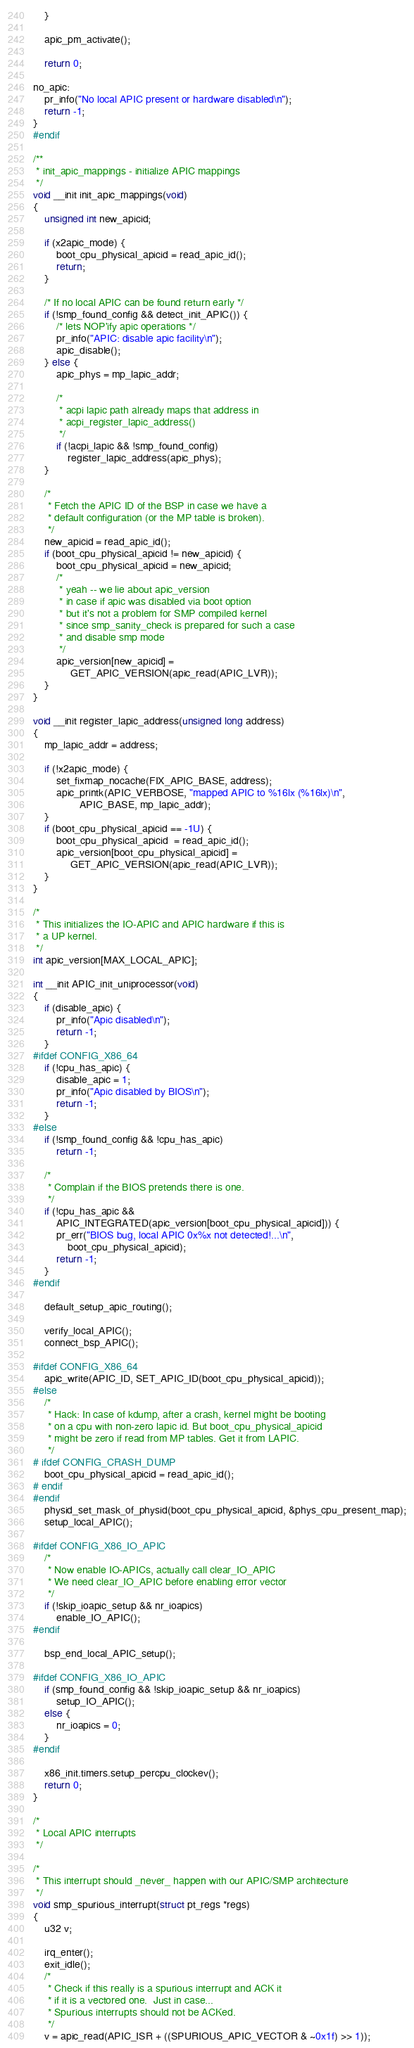Convert code to text. <code><loc_0><loc_0><loc_500><loc_500><_C_>	}

	apic_pm_activate();

	return 0;

no_apic:
	pr_info("No local APIC present or hardware disabled\n");
	return -1;
}
#endif

/**
 * init_apic_mappings - initialize APIC mappings
 */
void __init init_apic_mappings(void)
{
	unsigned int new_apicid;

	if (x2apic_mode) {
		boot_cpu_physical_apicid = read_apic_id();
		return;
	}

	/* If no local APIC can be found return early */
	if (!smp_found_config && detect_init_APIC()) {
		/* lets NOP'ify apic operations */
		pr_info("APIC: disable apic facility\n");
		apic_disable();
	} else {
		apic_phys = mp_lapic_addr;

		/*
		 * acpi lapic path already maps that address in
		 * acpi_register_lapic_address()
		 */
		if (!acpi_lapic && !smp_found_config)
			register_lapic_address(apic_phys);
	}

	/*
	 * Fetch the APIC ID of the BSP in case we have a
	 * default configuration (or the MP table is broken).
	 */
	new_apicid = read_apic_id();
	if (boot_cpu_physical_apicid != new_apicid) {
		boot_cpu_physical_apicid = new_apicid;
		/*
		 * yeah -- we lie about apic_version
		 * in case if apic was disabled via boot option
		 * but it's not a problem for SMP compiled kernel
		 * since smp_sanity_check is prepared for such a case
		 * and disable smp mode
		 */
		apic_version[new_apicid] =
			 GET_APIC_VERSION(apic_read(APIC_LVR));
	}
}

void __init register_lapic_address(unsigned long address)
{
	mp_lapic_addr = address;

	if (!x2apic_mode) {
		set_fixmap_nocache(FIX_APIC_BASE, address);
		apic_printk(APIC_VERBOSE, "mapped APIC to %16lx (%16lx)\n",
			    APIC_BASE, mp_lapic_addr);
	}
	if (boot_cpu_physical_apicid == -1U) {
		boot_cpu_physical_apicid  = read_apic_id();
		apic_version[boot_cpu_physical_apicid] =
			 GET_APIC_VERSION(apic_read(APIC_LVR));
	}
}

/*
 * This initializes the IO-APIC and APIC hardware if this is
 * a UP kernel.
 */
int apic_version[MAX_LOCAL_APIC];

int __init APIC_init_uniprocessor(void)
{
	if (disable_apic) {
		pr_info("Apic disabled\n");
		return -1;
	}
#ifdef CONFIG_X86_64
	if (!cpu_has_apic) {
		disable_apic = 1;
		pr_info("Apic disabled by BIOS\n");
		return -1;
	}
#else
	if (!smp_found_config && !cpu_has_apic)
		return -1;

	/*
	 * Complain if the BIOS pretends there is one.
	 */
	if (!cpu_has_apic &&
	    APIC_INTEGRATED(apic_version[boot_cpu_physical_apicid])) {
		pr_err("BIOS bug, local APIC 0x%x not detected!...\n",
			boot_cpu_physical_apicid);
		return -1;
	}
#endif

	default_setup_apic_routing();

	verify_local_APIC();
	connect_bsp_APIC();

#ifdef CONFIG_X86_64
	apic_write(APIC_ID, SET_APIC_ID(boot_cpu_physical_apicid));
#else
	/*
	 * Hack: In case of kdump, after a crash, kernel might be booting
	 * on a cpu with non-zero lapic id. But boot_cpu_physical_apicid
	 * might be zero if read from MP tables. Get it from LAPIC.
	 */
# ifdef CONFIG_CRASH_DUMP
	boot_cpu_physical_apicid = read_apic_id();
# endif
#endif
	physid_set_mask_of_physid(boot_cpu_physical_apicid, &phys_cpu_present_map);
	setup_local_APIC();

#ifdef CONFIG_X86_IO_APIC
	/*
	 * Now enable IO-APICs, actually call clear_IO_APIC
	 * We need clear_IO_APIC before enabling error vector
	 */
	if (!skip_ioapic_setup && nr_ioapics)
		enable_IO_APIC();
#endif

	bsp_end_local_APIC_setup();

#ifdef CONFIG_X86_IO_APIC
	if (smp_found_config && !skip_ioapic_setup && nr_ioapics)
		setup_IO_APIC();
	else {
		nr_ioapics = 0;
	}
#endif

	x86_init.timers.setup_percpu_clockev();
	return 0;
}

/*
 * Local APIC interrupts
 */

/*
 * This interrupt should _never_ happen with our APIC/SMP architecture
 */
void smp_spurious_interrupt(struct pt_regs *regs)
{
	u32 v;

	irq_enter();
	exit_idle();
	/*
	 * Check if this really is a spurious interrupt and ACK it
	 * if it is a vectored one.  Just in case...
	 * Spurious interrupts should not be ACKed.
	 */
	v = apic_read(APIC_ISR + ((SPURIOUS_APIC_VECTOR & ~0x1f) >> 1));</code> 